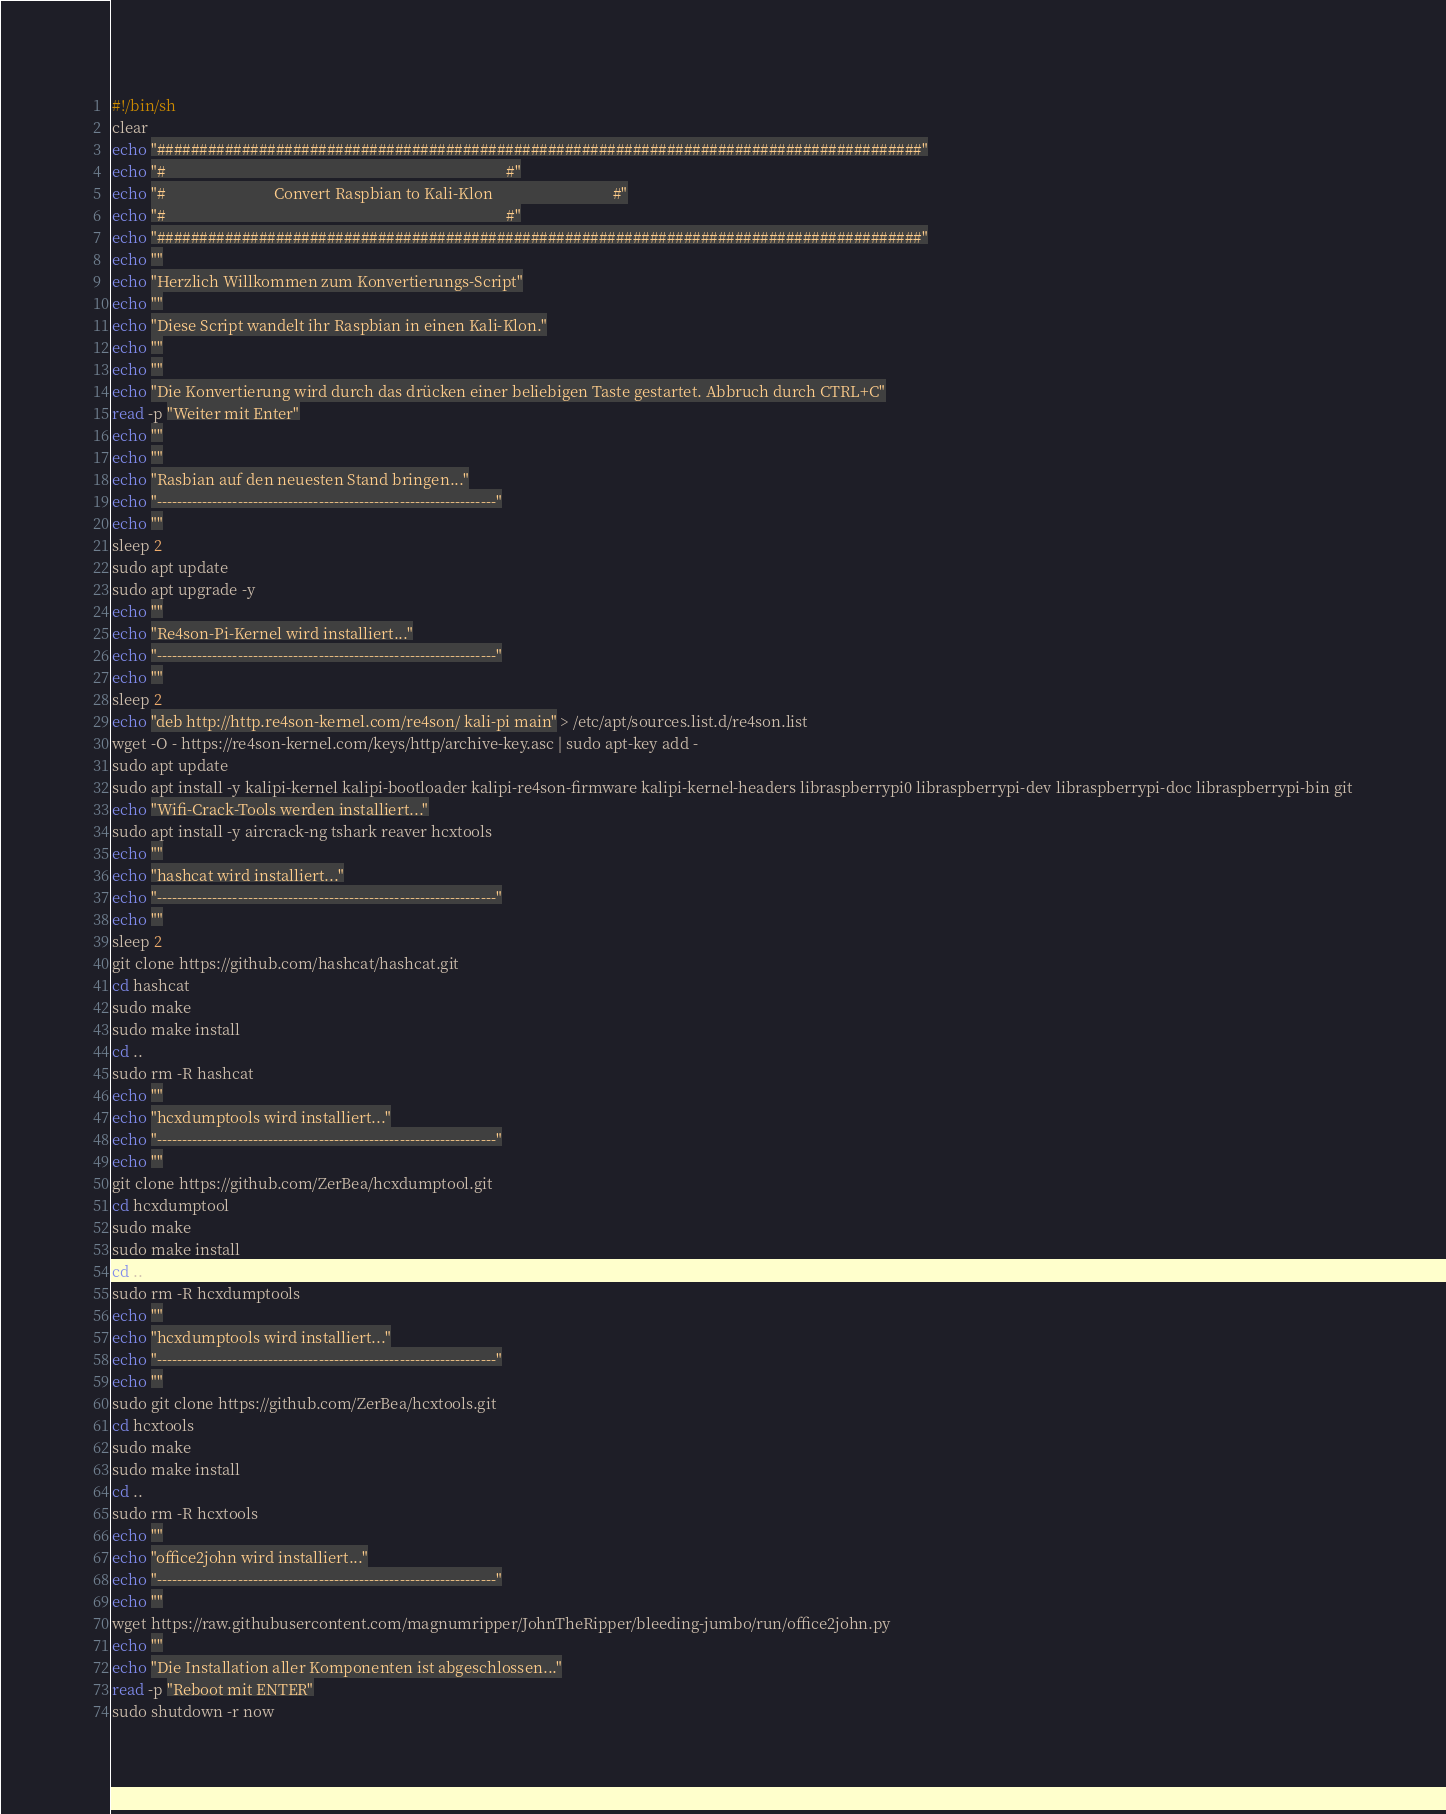<code> <loc_0><loc_0><loc_500><loc_500><_Bash_>#!/bin/sh
clear
echo "##########################################################################################"
echo "#                                                                                        #"
echo "#                            Convert Raspbian to Kali-Klon                               #"
echo "#                                                                                        #"
echo "##########################################################################################"
echo ""
echo "Herzlich Willkommen zum Konvertierungs-Script"
echo ""
echo "Diese Script wandelt ihr Raspbian in einen Kali-Klon."
echo ""
echo ""
echo "Die Konvertierung wird durch das drücken einer beliebigen Taste gestartet. Abbruch durch CTRL+C"
read -p "Weiter mit Enter"
echo ""
echo ""
echo "Rasbian auf den neuesten Stand bringen..."
echo "-------------------------------------------------------------------"
echo ""
sleep 2
sudo apt update
sudo apt upgrade -y
echo ""
echo "Re4son-Pi-Kernel wird installiert..."
echo "-------------------------------------------------------------------"
echo ""
sleep 2
echo "deb http://http.re4son-kernel.com/re4son/ kali-pi main" > /etc/apt/sources.list.d/re4son.list
wget -O - https://re4son-kernel.com/keys/http/archive-key.asc | sudo apt-key add -
sudo apt update
sudo apt install -y kalipi-kernel kalipi-bootloader kalipi-re4son-firmware kalipi-kernel-headers libraspberrypi0 libraspberrypi-dev libraspberrypi-doc libraspberrypi-bin git
echo "Wifi-Crack-Tools werden installiert..."
sudo apt install -y aircrack-ng tshark reaver hcxtools 
echo ""
echo "hashcat wird installiert..."
echo "-------------------------------------------------------------------"
echo ""
sleep 2
git clone https://github.com/hashcat/hashcat.git
cd hashcat
sudo make
sudo make install
cd ..
sudo rm -R hashcat
echo ""
echo "hcxdumptools wird installiert..."
echo "-------------------------------------------------------------------"
echo ""
git clone https://github.com/ZerBea/hcxdumptool.git
cd hcxdumptool
sudo make
sudo make install
cd ..
sudo rm -R hcxdumptools
echo ""
echo "hcxdumptools wird installiert..."
echo "-------------------------------------------------------------------"
echo ""
sudo git clone https://github.com/ZerBea/hcxtools.git
cd hcxtools
sudo make
sudo make install
cd ..
sudo rm -R hcxtools
echo ""
echo "office2john wird installiert..."
echo "-------------------------------------------------------------------"
echo ""
wget https://raw.githubusercontent.com/magnumripper/JohnTheRipper/bleeding-jumbo/run/office2john.py
echo ""
echo "Die Installation aller Komponenten ist abgeschlossen..."
read -p "Reboot mit ENTER"
sudo shutdown -r now
</code> 